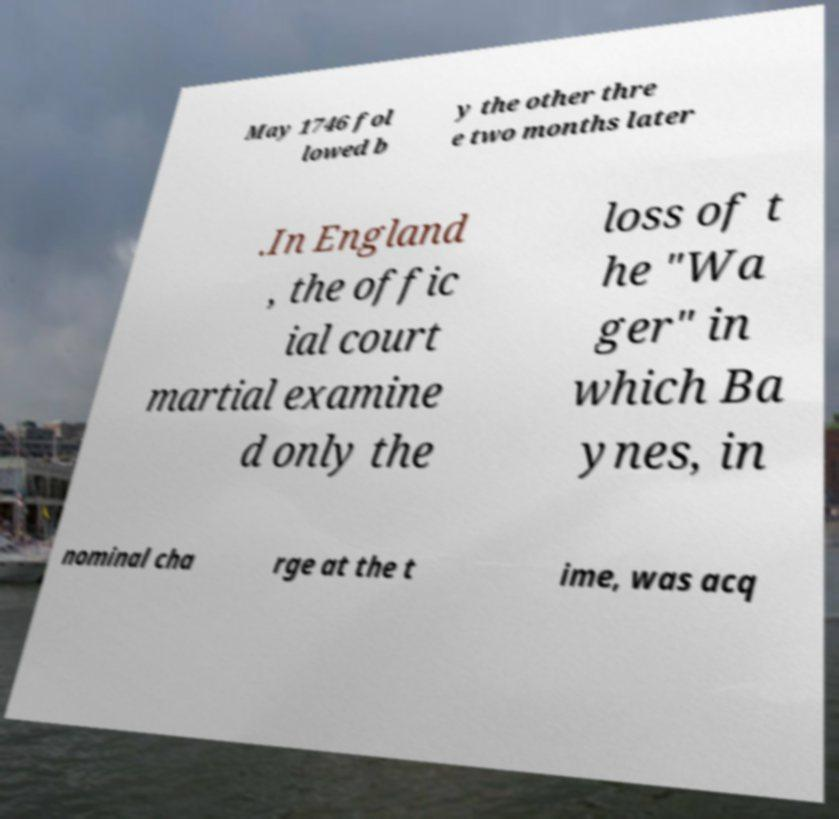For documentation purposes, I need the text within this image transcribed. Could you provide that? May 1746 fol lowed b y the other thre e two months later .In England , the offic ial court martial examine d only the loss of t he "Wa ger" in which Ba ynes, in nominal cha rge at the t ime, was acq 